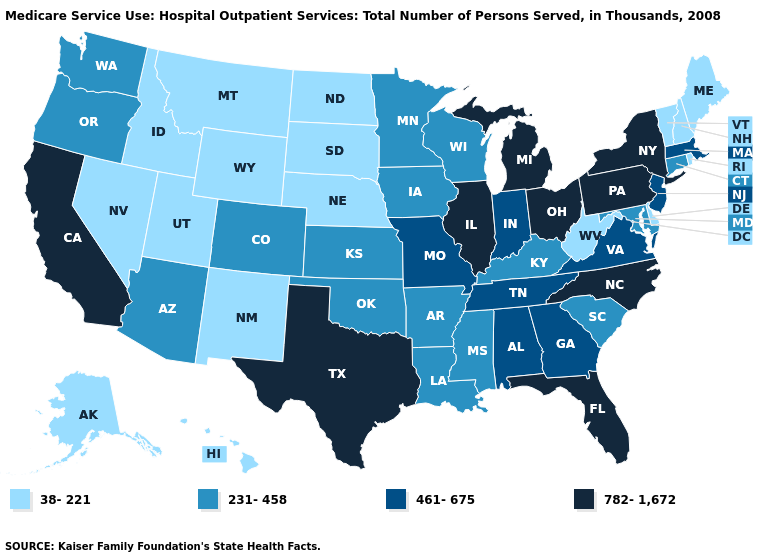What is the highest value in the Northeast ?
Quick response, please. 782-1,672. What is the lowest value in the USA?
Quick response, please. 38-221. What is the value of Arkansas?
Be succinct. 231-458. Name the states that have a value in the range 38-221?
Write a very short answer. Alaska, Delaware, Hawaii, Idaho, Maine, Montana, Nebraska, Nevada, New Hampshire, New Mexico, North Dakota, Rhode Island, South Dakota, Utah, Vermont, West Virginia, Wyoming. Does the map have missing data?
Concise answer only. No. Does the first symbol in the legend represent the smallest category?
Write a very short answer. Yes. Does Idaho have a higher value than Maryland?
Short answer required. No. Does Maine have the highest value in the USA?
Short answer required. No. Is the legend a continuous bar?
Give a very brief answer. No. Does Texas have the same value as North Carolina?
Short answer required. Yes. Which states have the lowest value in the Northeast?
Concise answer only. Maine, New Hampshire, Rhode Island, Vermont. Name the states that have a value in the range 231-458?
Answer briefly. Arizona, Arkansas, Colorado, Connecticut, Iowa, Kansas, Kentucky, Louisiana, Maryland, Minnesota, Mississippi, Oklahoma, Oregon, South Carolina, Washington, Wisconsin. Which states have the lowest value in the USA?
Quick response, please. Alaska, Delaware, Hawaii, Idaho, Maine, Montana, Nebraska, Nevada, New Hampshire, New Mexico, North Dakota, Rhode Island, South Dakota, Utah, Vermont, West Virginia, Wyoming. Which states have the lowest value in the USA?
Be succinct. Alaska, Delaware, Hawaii, Idaho, Maine, Montana, Nebraska, Nevada, New Hampshire, New Mexico, North Dakota, Rhode Island, South Dakota, Utah, Vermont, West Virginia, Wyoming. 